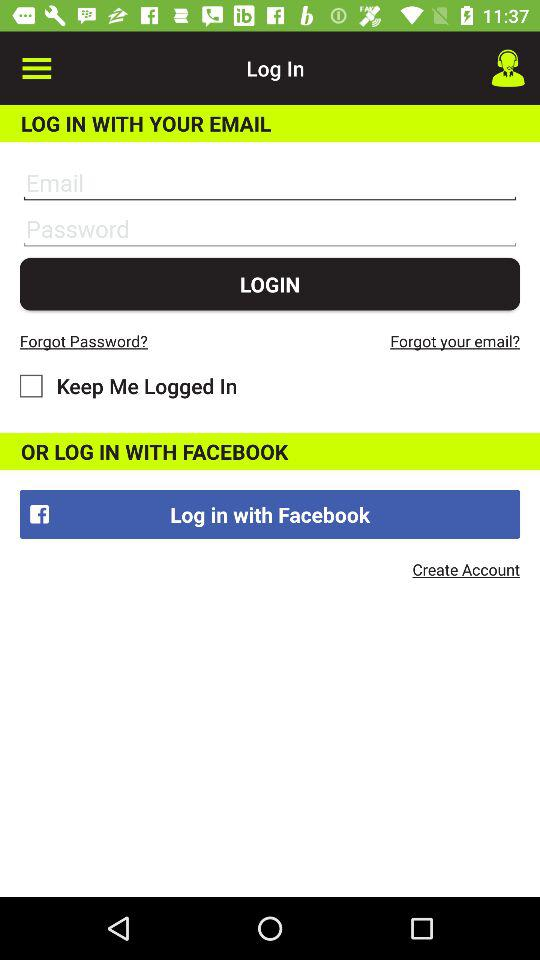How many input fields are there for logging in?
Answer the question using a single word or phrase. 2 